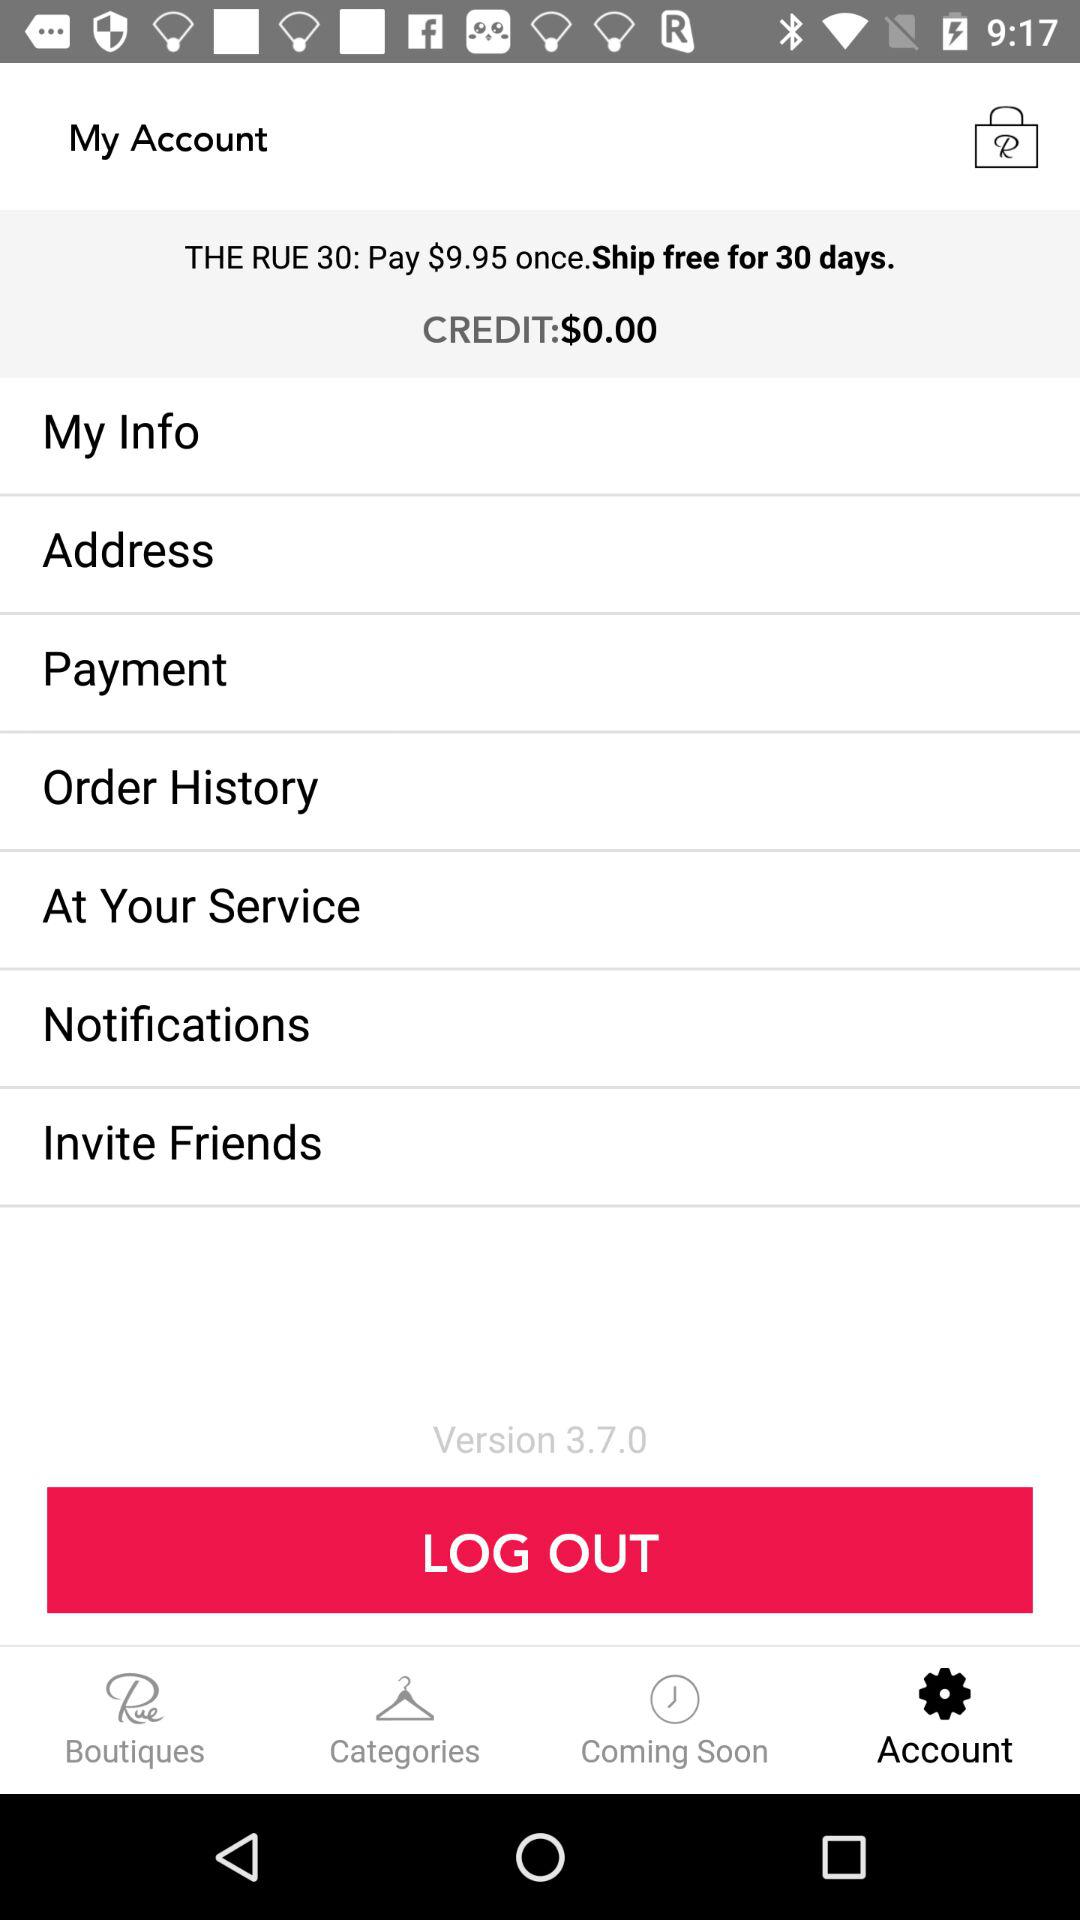What is the version? The version is 3.7.0. 